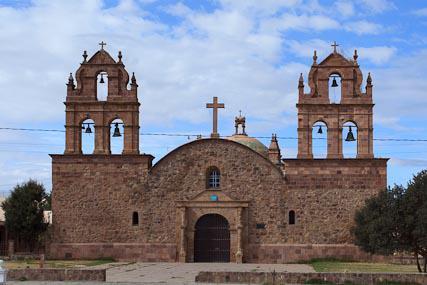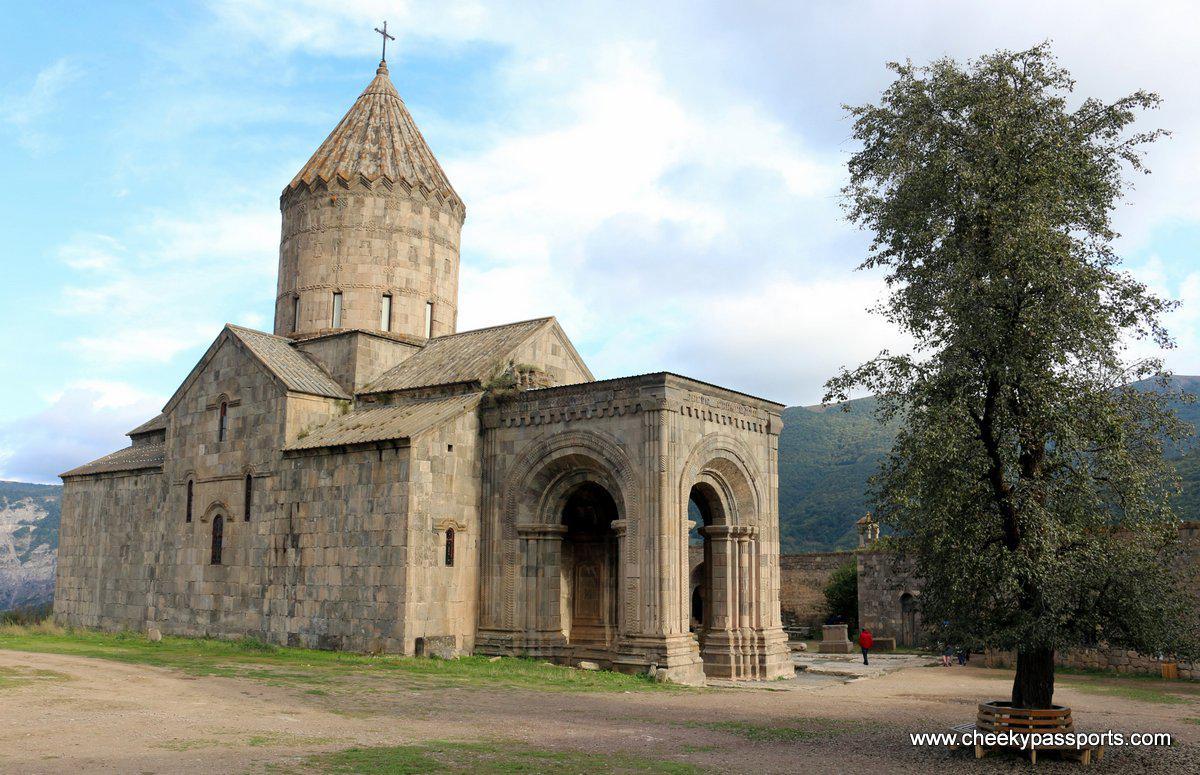The first image is the image on the left, the second image is the image on the right. Analyze the images presented: Is the assertion "The right image shows a beige building with a cone-shaped roof topped with a cross above a cylindrical tower." valid? Answer yes or no. Yes. 